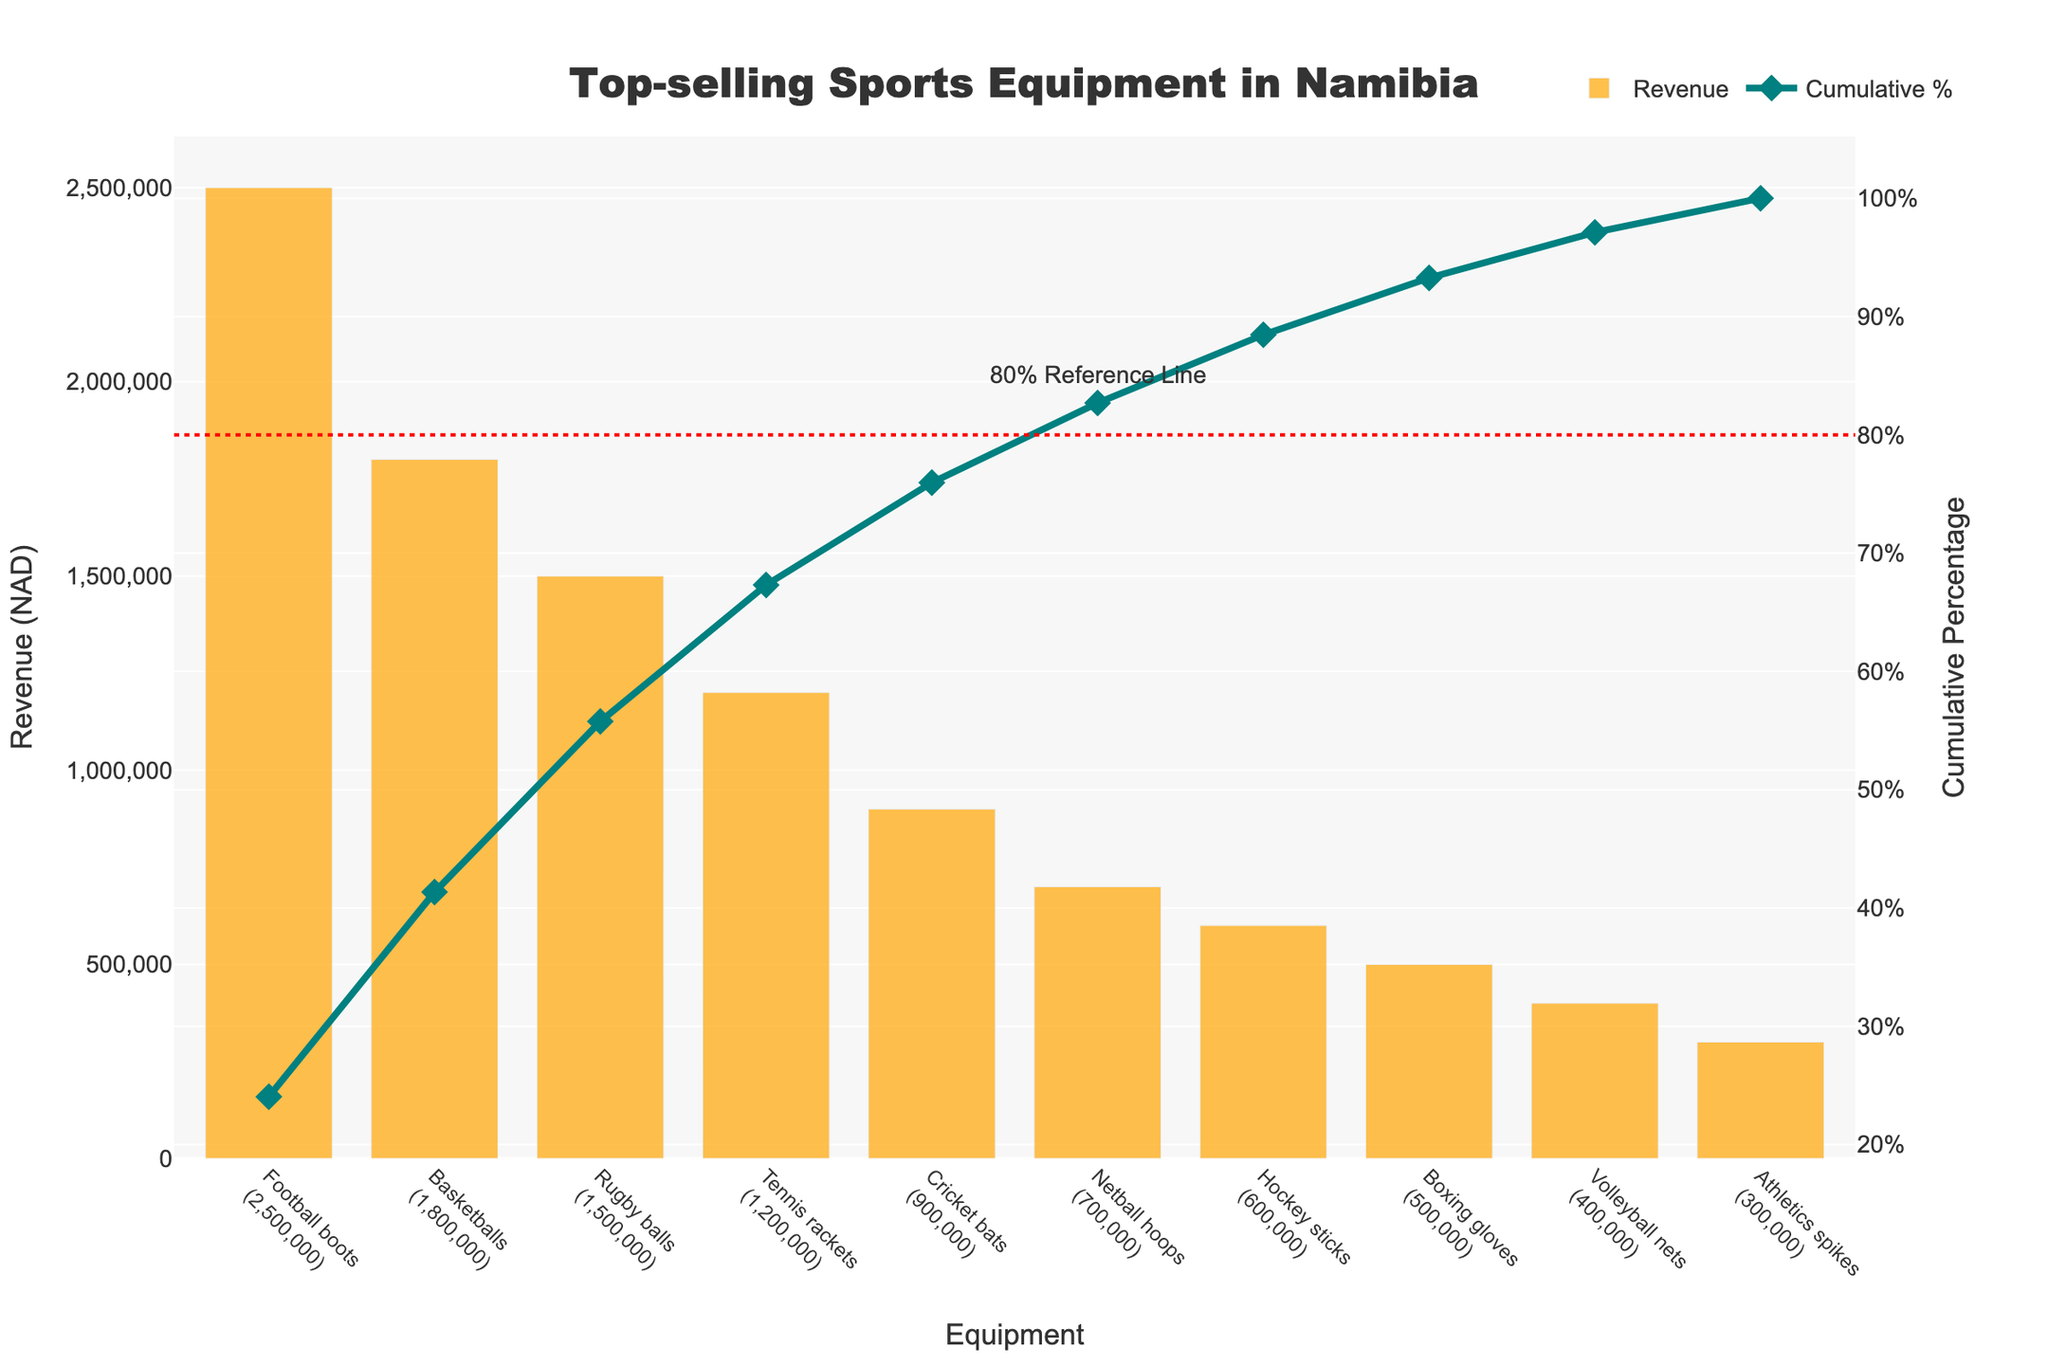What's the title of the chart? The title is explicitly located at the top of the chart. We can see it clearly written.
Answer: Top-selling Sports Equipment in Namibia What color is used for the bar chart representing revenue? The bars representing revenue are distinctly colored, making them easy to notice.
Answer: Orange Which sports equipment generated the highest revenue? To determine the highest revenue, we look at the tallest bar in the chart, which corresponds to the football boots.
Answer: Football boots At which data point does the cumulative percentage surpass 80%? By following the cumulative percentage line and locating where it crosses the 80% reference line, we can determine the position. The cumulative line crosses 80% between Netball hoops and Hockey sticks.
Answer: Netball hoops What's the cumulative percentage after the first four sports equipment? We should sum the cumulative percentage values of the first four equipment items from the cumulative percentage line. The values are precise and can be read off the chart.
Answer: 85% How much more revenue did football boots generate compared to athletics spikes? Locate the bars representing football boots and athletics spikes and subtract the revenue of athletics spikes from that of football boots.
Answer: 2,200,000 NAD What is the total revenue of the top three selling sports equipment? To determine the total revenue, we sum the revenues of the top three equipment: Football boots, Basketballs, and Rugby balls.
Answer: 5,800,000 NAD Is the revenue of rugby balls greater than the combined revenue of the bottom three items? Compare the revenue of rugby balls with the sum of the revenues of Volley ball nets, Boxing gloves, and Athletics spikes. Rugby balls generate 1,500,000 NAD, and the combined revenue of the bottom three is 1,200,000 NAD, so rugby balls' revenue is indeed higher.
Answer: Yes Which sports equipment contributed to exactly reaching the 80% cumulative percentage line? By examining the chart, we identify the cumulative percentage line. We find the cumulative percentage crosses 80% between Netball hoops and Hockey sticks, contributing precisely to this point.
Answer: Netball hoops Where is the 80% reference line annotated in the chart? The 80% reference line is positioned on the cumulative percentage axis with a red-dotted line and has an annotation above the equipment list.
Answer: Above the equipment list 